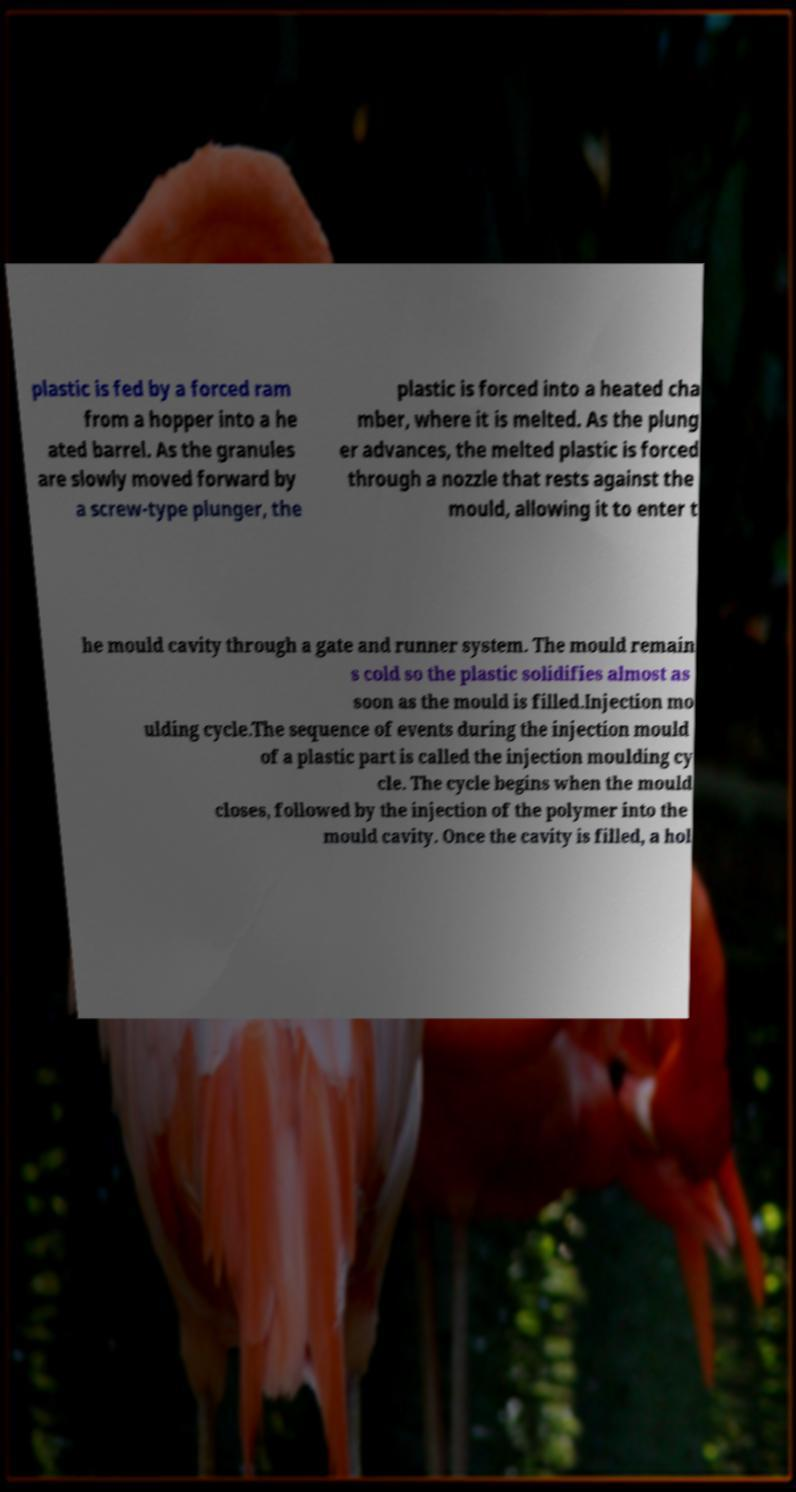I need the written content from this picture converted into text. Can you do that? plastic is fed by a forced ram from a hopper into a he ated barrel. As the granules are slowly moved forward by a screw-type plunger, the plastic is forced into a heated cha mber, where it is melted. As the plung er advances, the melted plastic is forced through a nozzle that rests against the mould, allowing it to enter t he mould cavity through a gate and runner system. The mould remain s cold so the plastic solidifies almost as soon as the mould is filled.Injection mo ulding cycle.The sequence of events during the injection mould of a plastic part is called the injection moulding cy cle. The cycle begins when the mould closes, followed by the injection of the polymer into the mould cavity. Once the cavity is filled, a hol 